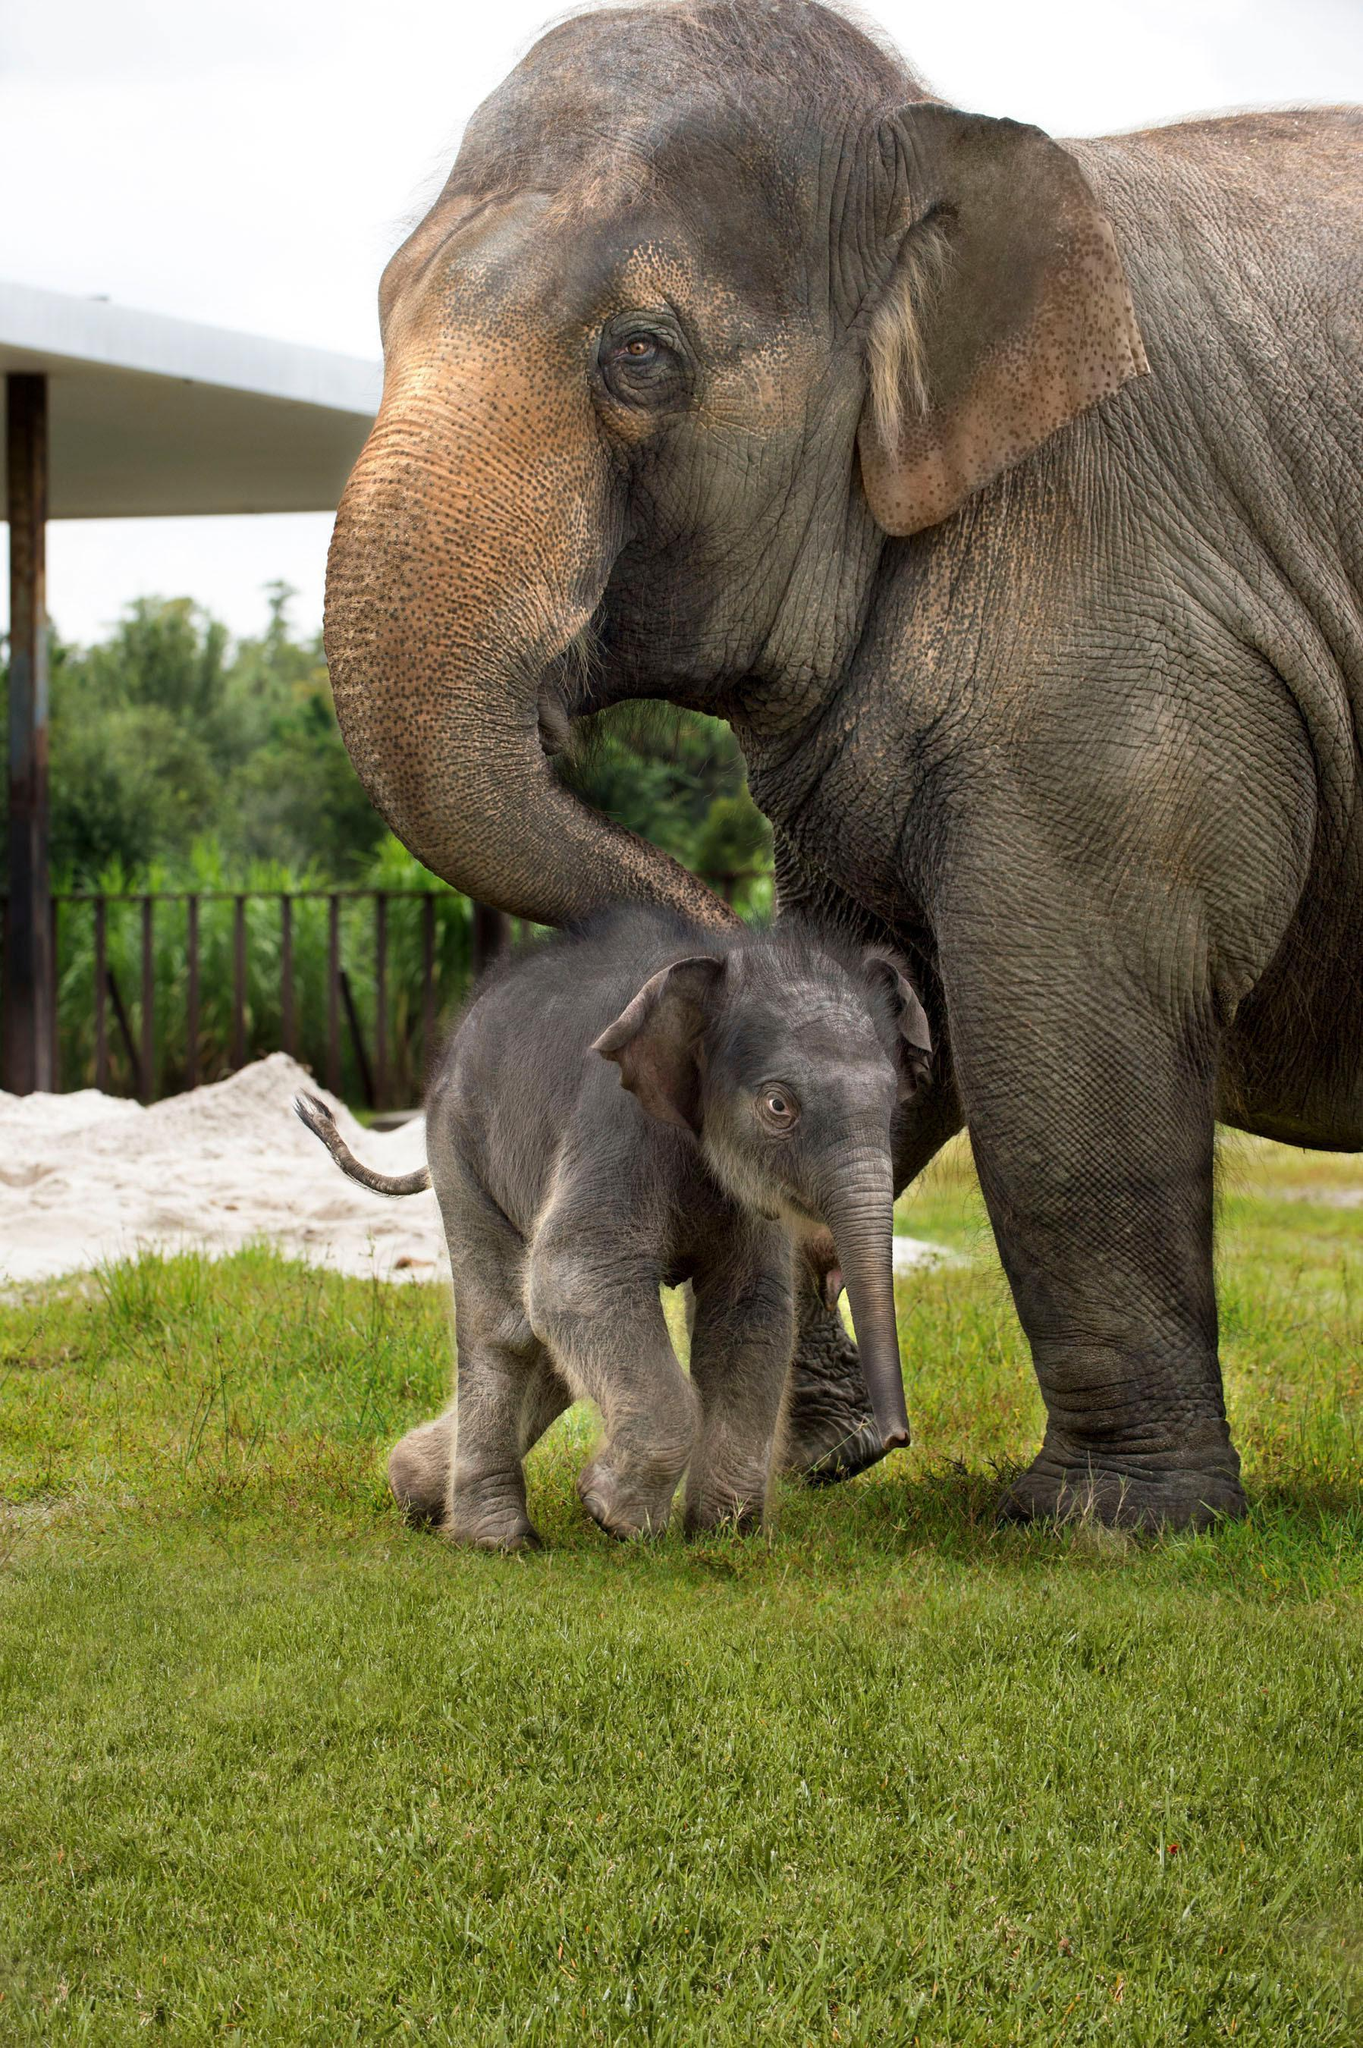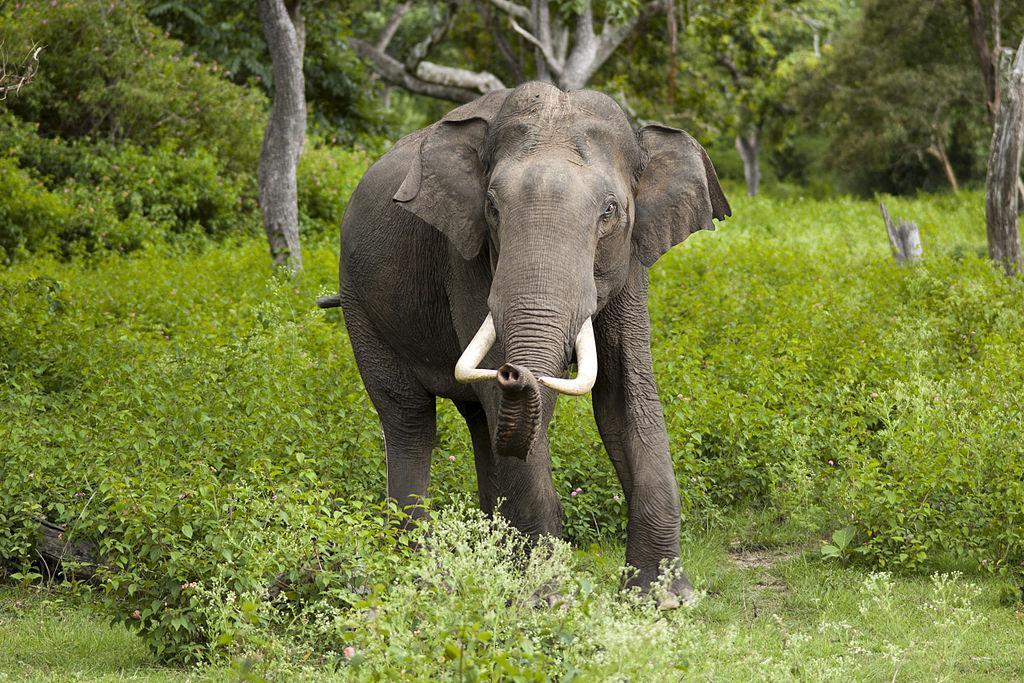The first image is the image on the left, the second image is the image on the right. Analyze the images presented: Is the assertion "At least one elephant is in the foreground of an image standing in water." valid? Answer yes or no. No. The first image is the image on the left, the second image is the image on the right. For the images displayed, is the sentence "At least one elephant is standing in water." factually correct? Answer yes or no. No. 